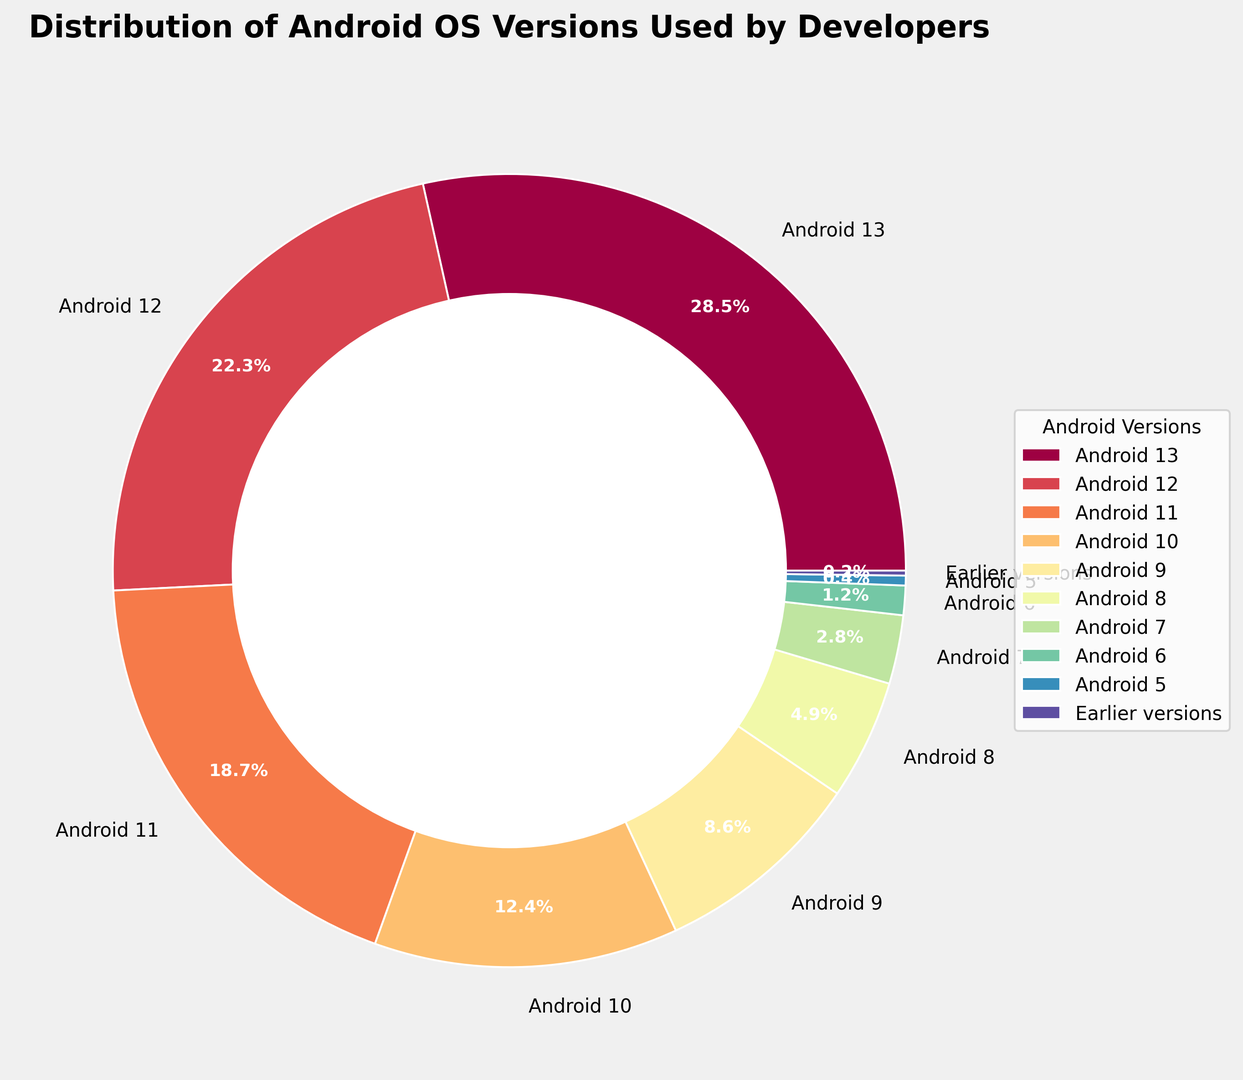What is the percentage of developers using Android 13? Look at the labeled wedge corresponding to Android 13. The percentage value is displayed on the chart.
Answer: 28.5% Which Android version is used by the smallest percentage of developers? Compare the percentages for each Android version and find the smallest value. Earlier versions have the smallest percentage.
Answer: Earlier versions What is the combined percentage of developers using Android 12 and Android 11? Add the percentages for Android 12 and Android 11. Android 12 is 22.3%, and Android 11 is 18.7%. The combined percentage is 22.3 + 18.7.
Answer: 41.0% Which color represents Android 10 on the chart? Identify the wedge labeled Android 10 and note its color.
Answer: The color varies according to the color scheme, described as one of the spectral colors How many Android versions have a usage percentage higher than 10%? Identify the wedges with a percentage higher than 10%. Count these wedges. The wedges are for Android 13, 12, 11, and 10.
Answer: 4 Is the percentage of developers using Android 9 greater than double the percentage of those using Android 8? Calculate and compare the percentages: 8.6% for Android 9 and 4.9% for Android 8. Double of 4.9% is 9.8%, which is greater than 8.6%.
Answer: No What is the combined percentage of developers using Android 9 and earlier versions? Add the percentages for Android 9 and earlier versions. Android 9 is 8.6%, and earlier versions are 0.2%. The combined percentage is 8.6 + 0.2.
Answer: 8.8% Compare the usage percentages of Android 8 and Android 7. Which one has a higher usage percentage? Look at the labels for Android 8 and Android 7. Android 8 has 4.9%, and Android 7 has 2.8%, so Android 8 is higher.
Answer: Android 8 If we grouped all versions earlier than Android 11 together, what would be their combined percentage? Add the percentages of Android 10, 9, 8, 7, 6, 5, and earlier versions. Sum is 12.4 + 8.6 + 4.9 + 2.8 + 1.2 + 0.4 + 0.2.
Answer: 30.5% Which Android version has a usage percentage closest to 5%? Compare the percentage values to 5%. Android 8 has 4.9%, which is the closest.
Answer: Android 8 